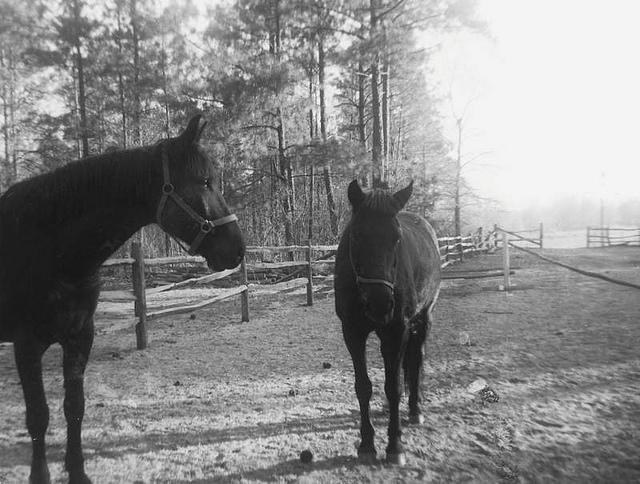Are the horses meant for riding?
Write a very short answer. Yes. Are these horses in a city?
Keep it brief. No. Is that fence made of metal?
Keep it brief. No. 